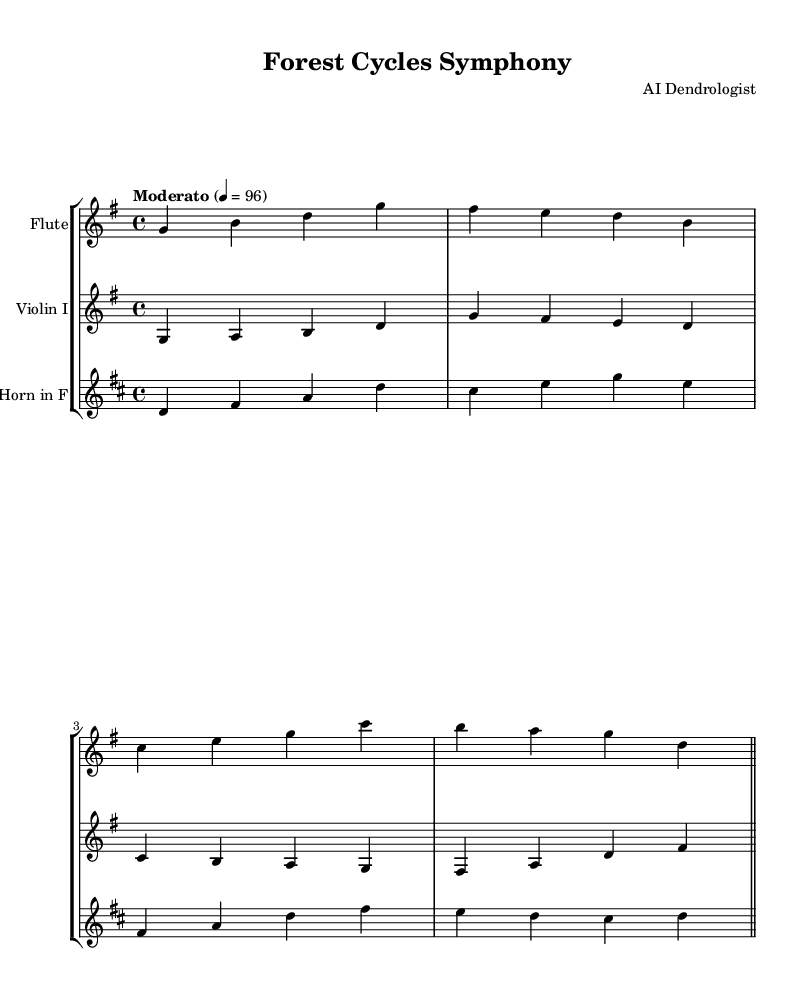What is the key signature of this music? The key signature is G major, which has one sharps (F#). This can be identified by the presence of a single sharp sign on the staff after the clef symbol.
Answer: G major What is the time signature of this music? The time signature is 4/4, which appears at the beginning of the score. It indicates that each measure contains four beats, and each quarter note gets one beat.
Answer: 4/4 What is the tempo marking for this composition? The tempo marking is Moderato, which is indicated in the header above the staff. It means a moderate speed of performance.
Answer: Moderato How many instruments are in the score? There are three instruments listed in the score: Flute, Violin I, and Horn in F. Each is shown in a separate staff within the staff group.
Answer: Three Which instrument is playing in the highest register? The Flute is in the highest register, as its notes (g, b, d, etc.) are notated in a higher octave compared to the Violin I and Horn parts.
Answer: Flute Which note appears most frequently in the Flute part? The note G appears most frequently in the Flute part, as it is repeated multiple times throughout the measures.
Answer: G What is the range of the Horn in this composition? The Horn's range is from the note B (in the bass clef) up to D (in the treble clef), which can be determined by examining the lowest and highest notes in the Horn part.
Answer: B to D 